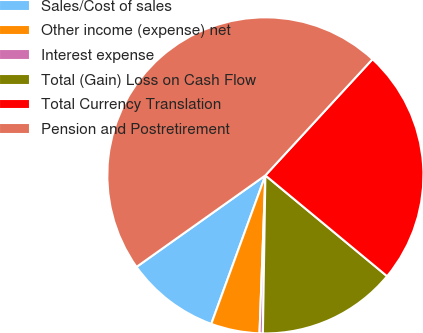<chart> <loc_0><loc_0><loc_500><loc_500><pie_chart><fcel>Sales/Cost of sales<fcel>Other income (expense) net<fcel>Interest expense<fcel>Total (Gain) Loss on Cash Flow<fcel>Total Currency Translation<fcel>Pension and Postretirement<nl><fcel>9.61%<fcel>4.97%<fcel>0.34%<fcel>14.24%<fcel>24.16%<fcel>46.68%<nl></chart> 